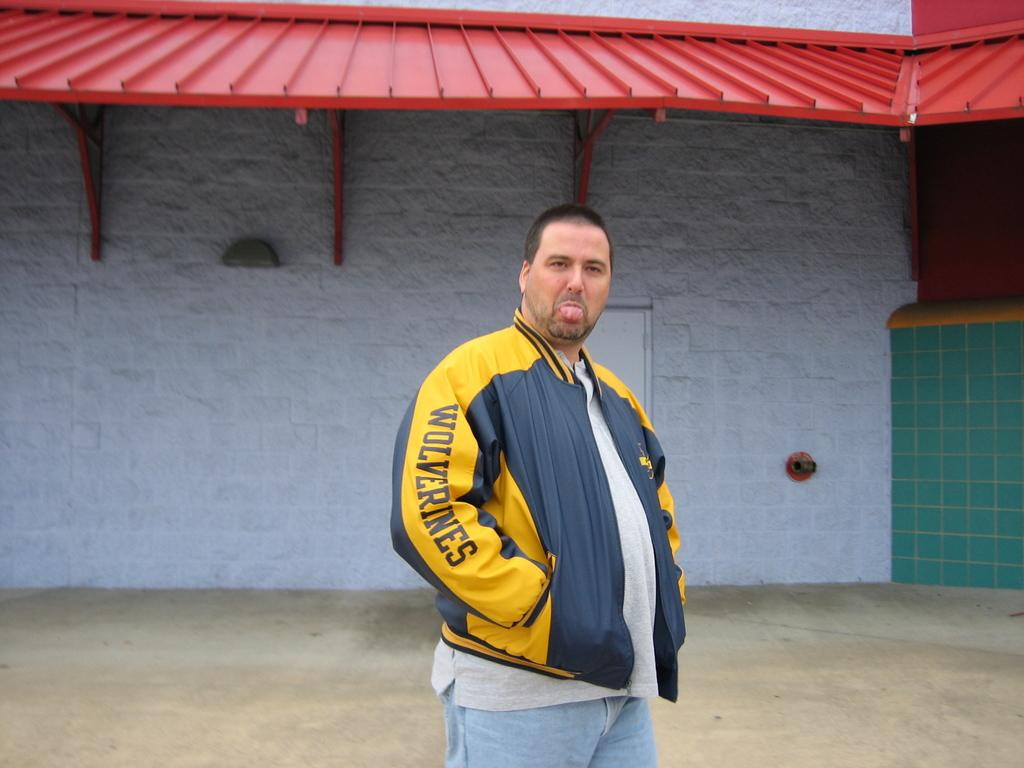<image>
Summarize the visual content of the image. a man wearing a wolverines coat is sticking out his tongue 